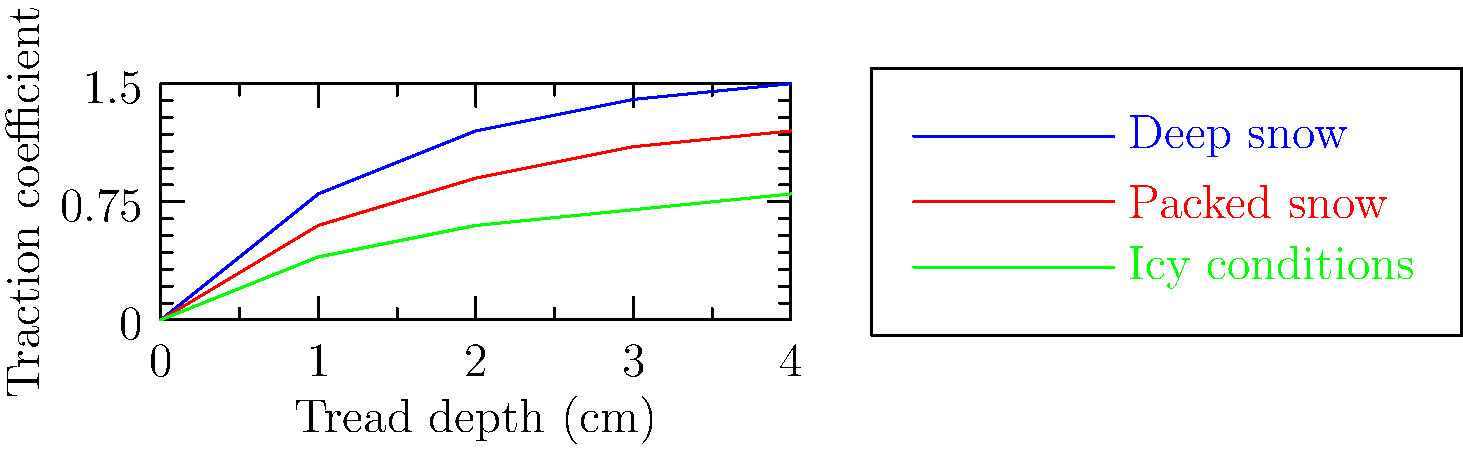As an Arctic exploration enthusiast, you're analyzing snowmobile track designs for various snow conditions. The graph shows the relationship between tread depth and traction coefficient for three snow types. Which tread depth (in cm) provides the highest traction coefficient across all snow conditions, and what is that coefficient? To solve this problem, we need to follow these steps:

1. Examine the graph for each snow condition:
   - Deep snow (blue line)
   - Packed snow (red line)
   - Icy conditions (green line)

2. Identify the point where all three lines are closest together vertically. This represents the tread depth that provides the most consistent traction across all conditions.

3. From the graph, we can see that the lines converge most closely at a tread depth of 2 cm.

4. At 2 cm tread depth, read the traction coefficient for each condition:
   - Deep snow: approximately 1.2
   - Packed snow: approximately 0.9
   - Icy conditions: approximately 0.6

5. The highest traction coefficient at 2 cm tread depth is 1.2 for deep snow.

Therefore, a tread depth of 2 cm provides the best overall performance across all snow conditions, with the highest traction coefficient being 1.2 in deep snow.
Answer: 2 cm tread depth; 1.2 traction coefficient 